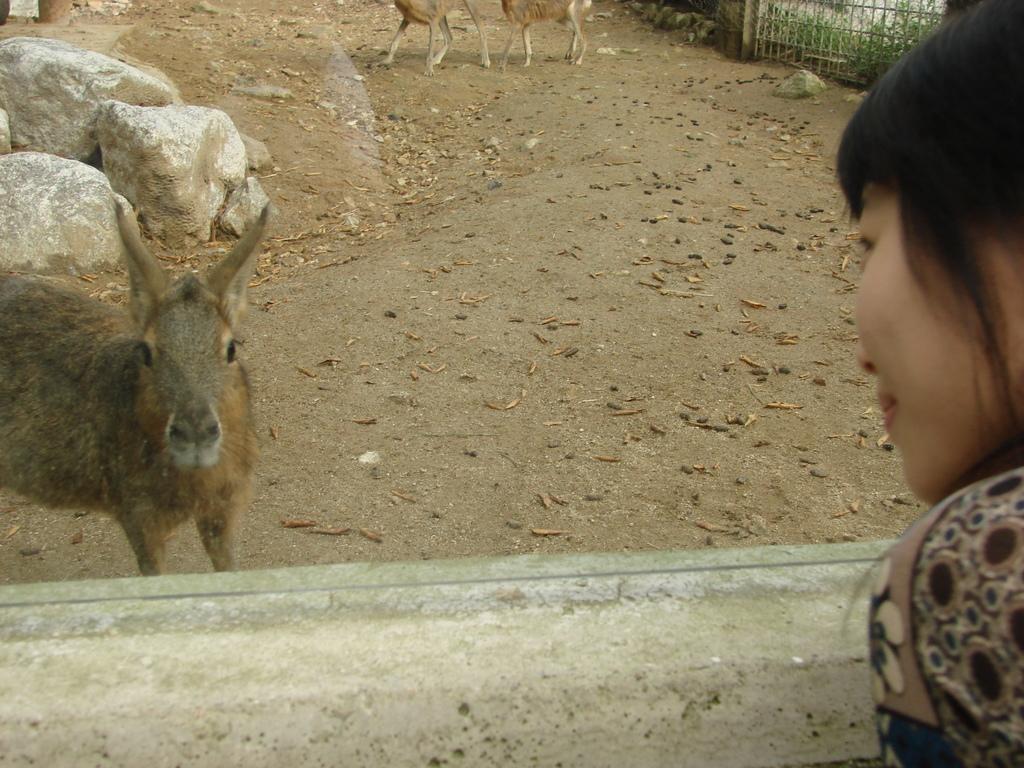Could you give a brief overview of what you see in this image? In this image we can see some animals on the ground. On the left side of the image we can see rocks. On the right side of the image we can see a woman standing. At the top of the image we can see a fence and some plants. 